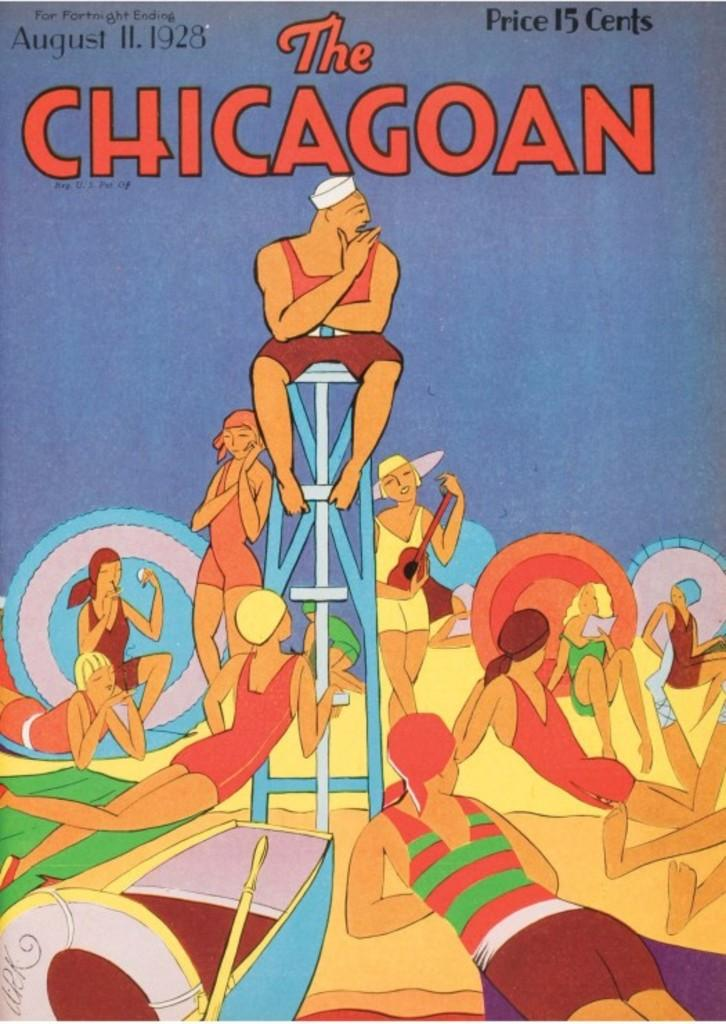What is the main subject of the cover page in the image? There is a cover page with text in the image. What are the people in the image wearing? The people in the image are wearing swimsuits. What type of vehicle is present in the image? There is a boat in the image. What objects are used for floating or support in the image? There are tubes and a stool in the image. What type of chicken is being served on the boat in the image? There is no chicken present in the image; it features a cover page, people in swimsuits, a boat, tubes, and a stool. 